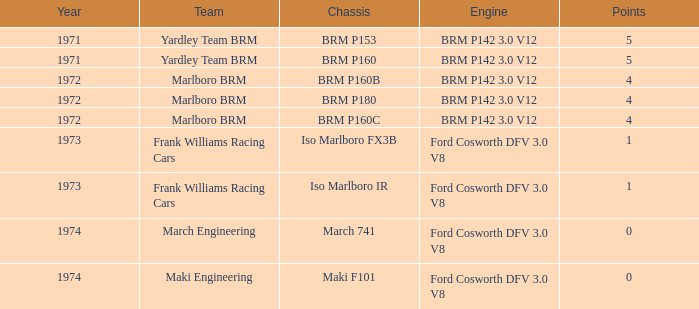What are the top accomplishments for the marlboro brm team using the brm p180 chassis? 4.0. 